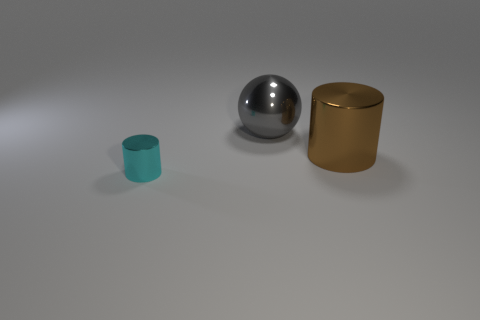Add 3 brown matte objects. How many objects exist? 6 Subtract all cylinders. How many objects are left? 1 Add 2 large shiny spheres. How many large shiny spheres exist? 3 Subtract 0 red cylinders. How many objects are left? 3 Subtract all cyan metallic things. Subtract all big gray balls. How many objects are left? 1 Add 1 big metal spheres. How many big metal spheres are left? 2 